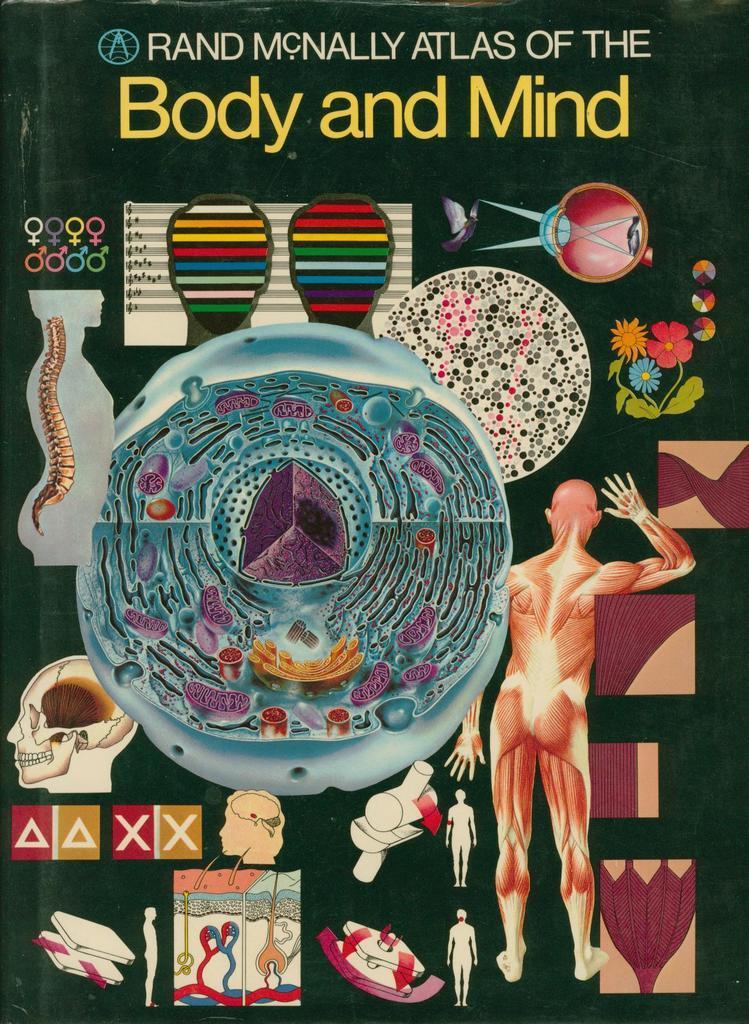How would you summarize this image in a sentence or two? In the image there is a black color poster with animated body parts. There are muscles, spinal cord, skull and many other parts. At the top of the image there is a name on the poster. 